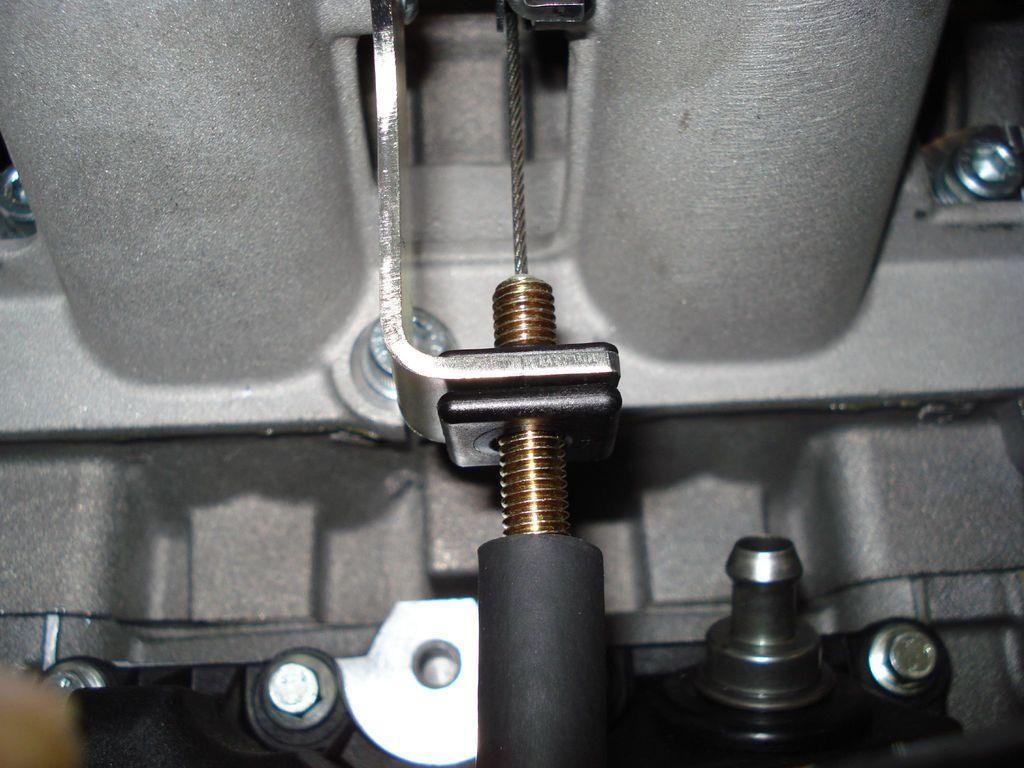In one or two sentences, can you explain what this image depicts? In this image, we can see, there are nuts, a hole and there are pipes. 